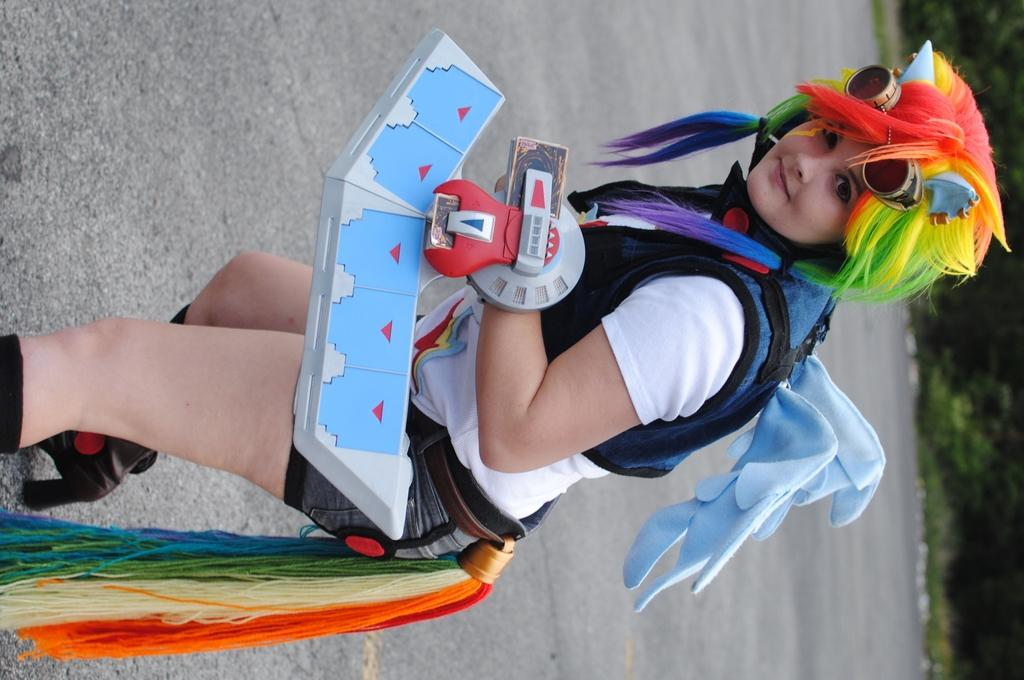Who is the main subject in the image? There is a woman in the image. What is the woman wearing? The woman is wearing a cosplay attire. What can be observed about the woman's hair? The woman has a colorful wig. Where is the woman standing in the image? The woman is standing on a road. What can be seen in the background of the image? There are trees visible in the background. How is the image oriented? The image is in a vertical orientation. What type of farming equipment can be seen in the image? There is no farming equipment present in the image. What does the woman's mom think about her cosplay attire? The image does not provide any information about the woman's mom or her opinion on the cosplay attire. --- 